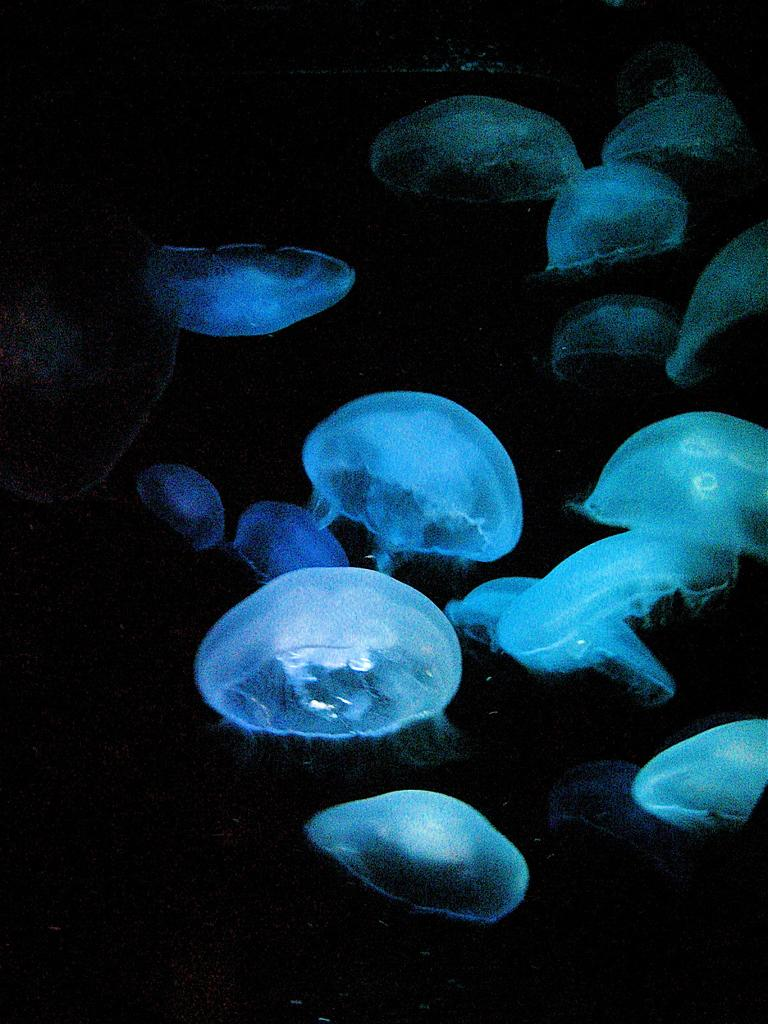What type of animals are in the image? There is a group of jellyfish in the image. Where are the jellyfish located? The jellyfish are in the water. What type of veil is being used by the jellyfish in the image? There is no veil present in the image; jellyfish do not wear veils. 